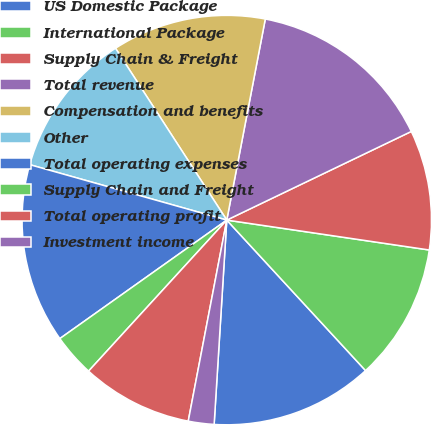Convert chart. <chart><loc_0><loc_0><loc_500><loc_500><pie_chart><fcel>US Domestic Package<fcel>International Package<fcel>Supply Chain & Freight<fcel>Total revenue<fcel>Compensation and benefits<fcel>Other<fcel>Total operating expenses<fcel>Supply Chain and Freight<fcel>Total operating profit<fcel>Investment income<nl><fcel>12.84%<fcel>10.81%<fcel>9.46%<fcel>14.86%<fcel>12.16%<fcel>11.49%<fcel>14.19%<fcel>3.38%<fcel>8.78%<fcel>2.03%<nl></chart> 